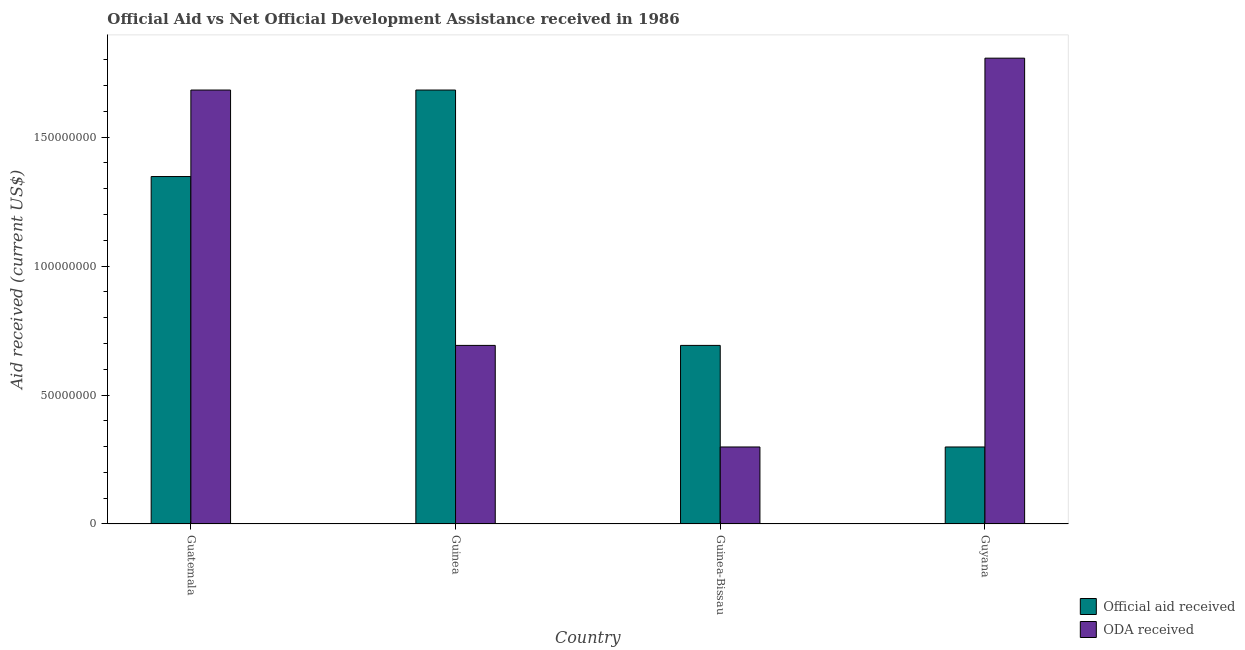How many groups of bars are there?
Provide a short and direct response. 4. Are the number of bars per tick equal to the number of legend labels?
Your answer should be compact. Yes. How many bars are there on the 2nd tick from the right?
Give a very brief answer. 2. What is the label of the 1st group of bars from the left?
Give a very brief answer. Guatemala. In how many cases, is the number of bars for a given country not equal to the number of legend labels?
Your response must be concise. 0. What is the official aid received in Guyana?
Your answer should be compact. 2.99e+07. Across all countries, what is the maximum official aid received?
Your answer should be compact. 1.68e+08. Across all countries, what is the minimum official aid received?
Provide a short and direct response. 2.99e+07. In which country was the oda received maximum?
Make the answer very short. Guyana. In which country was the official aid received minimum?
Ensure brevity in your answer.  Guyana. What is the total official aid received in the graph?
Give a very brief answer. 4.02e+08. What is the difference between the oda received in Guatemala and that in Guinea?
Give a very brief answer. 9.90e+07. What is the difference between the oda received in Guinea and the official aid received in Guatemala?
Keep it short and to the point. -6.55e+07. What is the average oda received per country?
Offer a very short reply. 1.12e+08. What is the difference between the official aid received and oda received in Guinea-Bissau?
Provide a succinct answer. 3.94e+07. In how many countries, is the oda received greater than 80000000 US$?
Offer a very short reply. 2. What is the ratio of the oda received in Guatemala to that in Guinea?
Provide a short and direct response. 2.43. Is the difference between the oda received in Guatemala and Guinea greater than the difference between the official aid received in Guatemala and Guinea?
Provide a succinct answer. Yes. What is the difference between the highest and the second highest official aid received?
Provide a succinct answer. 3.35e+07. What is the difference between the highest and the lowest official aid received?
Provide a short and direct response. 1.38e+08. In how many countries, is the official aid received greater than the average official aid received taken over all countries?
Provide a short and direct response. 2. What does the 1st bar from the left in Guinea-Bissau represents?
Ensure brevity in your answer.  Official aid received. What does the 2nd bar from the right in Guyana represents?
Make the answer very short. Official aid received. How many bars are there?
Make the answer very short. 8. Are all the bars in the graph horizontal?
Offer a very short reply. No. Are the values on the major ticks of Y-axis written in scientific E-notation?
Provide a succinct answer. No. Does the graph contain grids?
Offer a terse response. No. How many legend labels are there?
Provide a short and direct response. 2. How are the legend labels stacked?
Your answer should be compact. Vertical. What is the title of the graph?
Give a very brief answer. Official Aid vs Net Official Development Assistance received in 1986 . What is the label or title of the X-axis?
Offer a very short reply. Country. What is the label or title of the Y-axis?
Make the answer very short. Aid received (current US$). What is the Aid received (current US$) in Official aid received in Guatemala?
Ensure brevity in your answer.  1.35e+08. What is the Aid received (current US$) of ODA received in Guatemala?
Ensure brevity in your answer.  1.68e+08. What is the Aid received (current US$) of Official aid received in Guinea?
Offer a terse response. 1.68e+08. What is the Aid received (current US$) of ODA received in Guinea?
Your answer should be very brief. 6.92e+07. What is the Aid received (current US$) in Official aid received in Guinea-Bissau?
Provide a short and direct response. 6.92e+07. What is the Aid received (current US$) in ODA received in Guinea-Bissau?
Ensure brevity in your answer.  2.99e+07. What is the Aid received (current US$) in Official aid received in Guyana?
Provide a succinct answer. 2.99e+07. What is the Aid received (current US$) of ODA received in Guyana?
Provide a succinct answer. 1.81e+08. Across all countries, what is the maximum Aid received (current US$) in Official aid received?
Your answer should be compact. 1.68e+08. Across all countries, what is the maximum Aid received (current US$) of ODA received?
Your answer should be very brief. 1.81e+08. Across all countries, what is the minimum Aid received (current US$) of Official aid received?
Give a very brief answer. 2.99e+07. Across all countries, what is the minimum Aid received (current US$) in ODA received?
Offer a very short reply. 2.99e+07. What is the total Aid received (current US$) in Official aid received in the graph?
Provide a succinct answer. 4.02e+08. What is the total Aid received (current US$) of ODA received in the graph?
Your response must be concise. 4.48e+08. What is the difference between the Aid received (current US$) in Official aid received in Guatemala and that in Guinea?
Offer a very short reply. -3.35e+07. What is the difference between the Aid received (current US$) of ODA received in Guatemala and that in Guinea?
Ensure brevity in your answer.  9.90e+07. What is the difference between the Aid received (current US$) in Official aid received in Guatemala and that in Guinea-Bissau?
Provide a succinct answer. 6.55e+07. What is the difference between the Aid received (current US$) of ODA received in Guatemala and that in Guinea-Bissau?
Offer a very short reply. 1.38e+08. What is the difference between the Aid received (current US$) of Official aid received in Guatemala and that in Guyana?
Offer a very short reply. 1.05e+08. What is the difference between the Aid received (current US$) of ODA received in Guatemala and that in Guyana?
Keep it short and to the point. -1.24e+07. What is the difference between the Aid received (current US$) of Official aid received in Guinea and that in Guinea-Bissau?
Your answer should be very brief. 9.90e+07. What is the difference between the Aid received (current US$) of ODA received in Guinea and that in Guinea-Bissau?
Provide a succinct answer. 3.94e+07. What is the difference between the Aid received (current US$) in Official aid received in Guinea and that in Guyana?
Offer a terse response. 1.38e+08. What is the difference between the Aid received (current US$) in ODA received in Guinea and that in Guyana?
Offer a terse response. -1.11e+08. What is the difference between the Aid received (current US$) in Official aid received in Guinea-Bissau and that in Guyana?
Your answer should be compact. 3.94e+07. What is the difference between the Aid received (current US$) of ODA received in Guinea-Bissau and that in Guyana?
Ensure brevity in your answer.  -1.51e+08. What is the difference between the Aid received (current US$) in Official aid received in Guatemala and the Aid received (current US$) in ODA received in Guinea?
Make the answer very short. 6.55e+07. What is the difference between the Aid received (current US$) in Official aid received in Guatemala and the Aid received (current US$) in ODA received in Guinea-Bissau?
Provide a succinct answer. 1.05e+08. What is the difference between the Aid received (current US$) of Official aid received in Guatemala and the Aid received (current US$) of ODA received in Guyana?
Your answer should be very brief. -4.59e+07. What is the difference between the Aid received (current US$) of Official aid received in Guinea and the Aid received (current US$) of ODA received in Guinea-Bissau?
Your answer should be compact. 1.38e+08. What is the difference between the Aid received (current US$) of Official aid received in Guinea and the Aid received (current US$) of ODA received in Guyana?
Make the answer very short. -1.24e+07. What is the difference between the Aid received (current US$) of Official aid received in Guinea-Bissau and the Aid received (current US$) of ODA received in Guyana?
Ensure brevity in your answer.  -1.11e+08. What is the average Aid received (current US$) in Official aid received per country?
Make the answer very short. 1.01e+08. What is the average Aid received (current US$) in ODA received per country?
Your answer should be compact. 1.12e+08. What is the difference between the Aid received (current US$) of Official aid received and Aid received (current US$) of ODA received in Guatemala?
Offer a terse response. -3.35e+07. What is the difference between the Aid received (current US$) of Official aid received and Aid received (current US$) of ODA received in Guinea?
Your answer should be compact. 9.90e+07. What is the difference between the Aid received (current US$) of Official aid received and Aid received (current US$) of ODA received in Guinea-Bissau?
Offer a terse response. 3.94e+07. What is the difference between the Aid received (current US$) of Official aid received and Aid received (current US$) of ODA received in Guyana?
Ensure brevity in your answer.  -1.51e+08. What is the ratio of the Aid received (current US$) in Official aid received in Guatemala to that in Guinea?
Offer a terse response. 0.8. What is the ratio of the Aid received (current US$) in ODA received in Guatemala to that in Guinea?
Make the answer very short. 2.43. What is the ratio of the Aid received (current US$) in Official aid received in Guatemala to that in Guinea-Bissau?
Offer a very short reply. 1.95. What is the ratio of the Aid received (current US$) in ODA received in Guatemala to that in Guinea-Bissau?
Provide a short and direct response. 5.64. What is the ratio of the Aid received (current US$) in Official aid received in Guatemala to that in Guyana?
Your answer should be very brief. 4.51. What is the ratio of the Aid received (current US$) of ODA received in Guatemala to that in Guyana?
Make the answer very short. 0.93. What is the ratio of the Aid received (current US$) in Official aid received in Guinea to that in Guinea-Bissau?
Keep it short and to the point. 2.43. What is the ratio of the Aid received (current US$) of ODA received in Guinea to that in Guinea-Bissau?
Offer a very short reply. 2.32. What is the ratio of the Aid received (current US$) in Official aid received in Guinea to that in Guyana?
Provide a short and direct response. 5.64. What is the ratio of the Aid received (current US$) of ODA received in Guinea to that in Guyana?
Make the answer very short. 0.38. What is the ratio of the Aid received (current US$) of Official aid received in Guinea-Bissau to that in Guyana?
Keep it short and to the point. 2.32. What is the ratio of the Aid received (current US$) in ODA received in Guinea-Bissau to that in Guyana?
Ensure brevity in your answer.  0.17. What is the difference between the highest and the second highest Aid received (current US$) of Official aid received?
Keep it short and to the point. 3.35e+07. What is the difference between the highest and the second highest Aid received (current US$) of ODA received?
Ensure brevity in your answer.  1.24e+07. What is the difference between the highest and the lowest Aid received (current US$) in Official aid received?
Ensure brevity in your answer.  1.38e+08. What is the difference between the highest and the lowest Aid received (current US$) in ODA received?
Keep it short and to the point. 1.51e+08. 